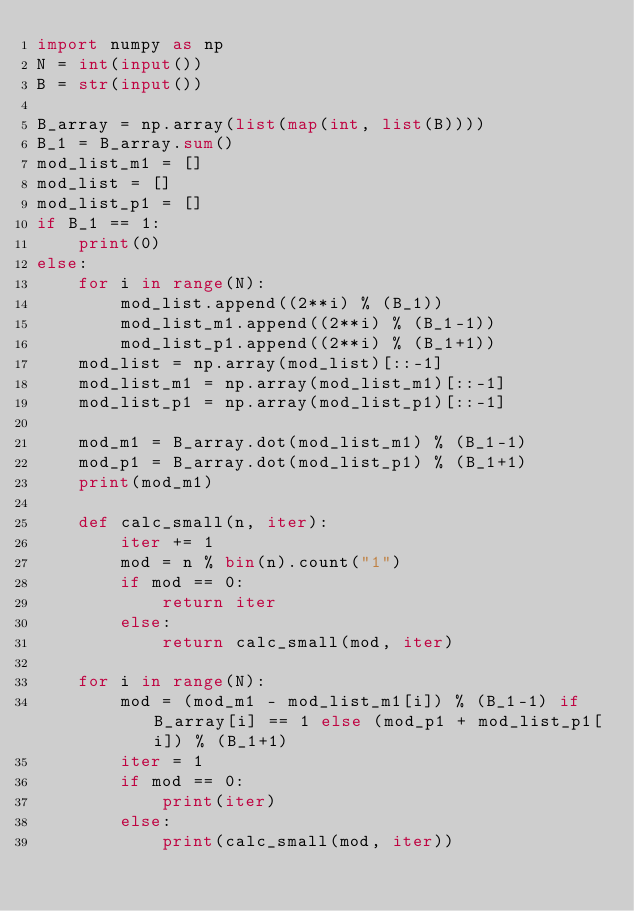Convert code to text. <code><loc_0><loc_0><loc_500><loc_500><_Python_>import numpy as np
N = int(input())
B = str(input())

B_array = np.array(list(map(int, list(B))))
B_1 = B_array.sum()
mod_list_m1 = []
mod_list = []
mod_list_p1 = []
if B_1 == 1:
    print(0)
else:
    for i in range(N):
        mod_list.append((2**i) % (B_1))
        mod_list_m1.append((2**i) % (B_1-1))
        mod_list_p1.append((2**i) % (B_1+1))
    mod_list = np.array(mod_list)[::-1]
    mod_list_m1 = np.array(mod_list_m1)[::-1]
    mod_list_p1 = np.array(mod_list_p1)[::-1]

    mod_m1 = B_array.dot(mod_list_m1) % (B_1-1)
    mod_p1 = B_array.dot(mod_list_p1) % (B_1+1)
    print(mod_m1)

    def calc_small(n, iter):
        iter += 1
        mod = n % bin(n).count("1")
        if mod == 0:
            return iter
        else:
            return calc_small(mod, iter)

    for i in range(N):
        mod = (mod_m1 - mod_list_m1[i]) % (B_1-1) if B_array[i] == 1 else (mod_p1 + mod_list_p1[i]) % (B_1+1)
        iter = 1
        if mod == 0:
            print(iter)
        else:
            print(calc_small(mod, iter))</code> 